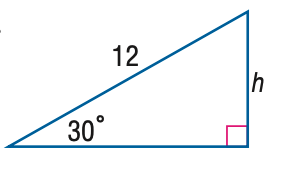Question: Find h.
Choices:
A. 3
B. 6
C. 6 \sqrt { 2 }
D. 6 \sqrt { 3 }
Answer with the letter. Answer: B 